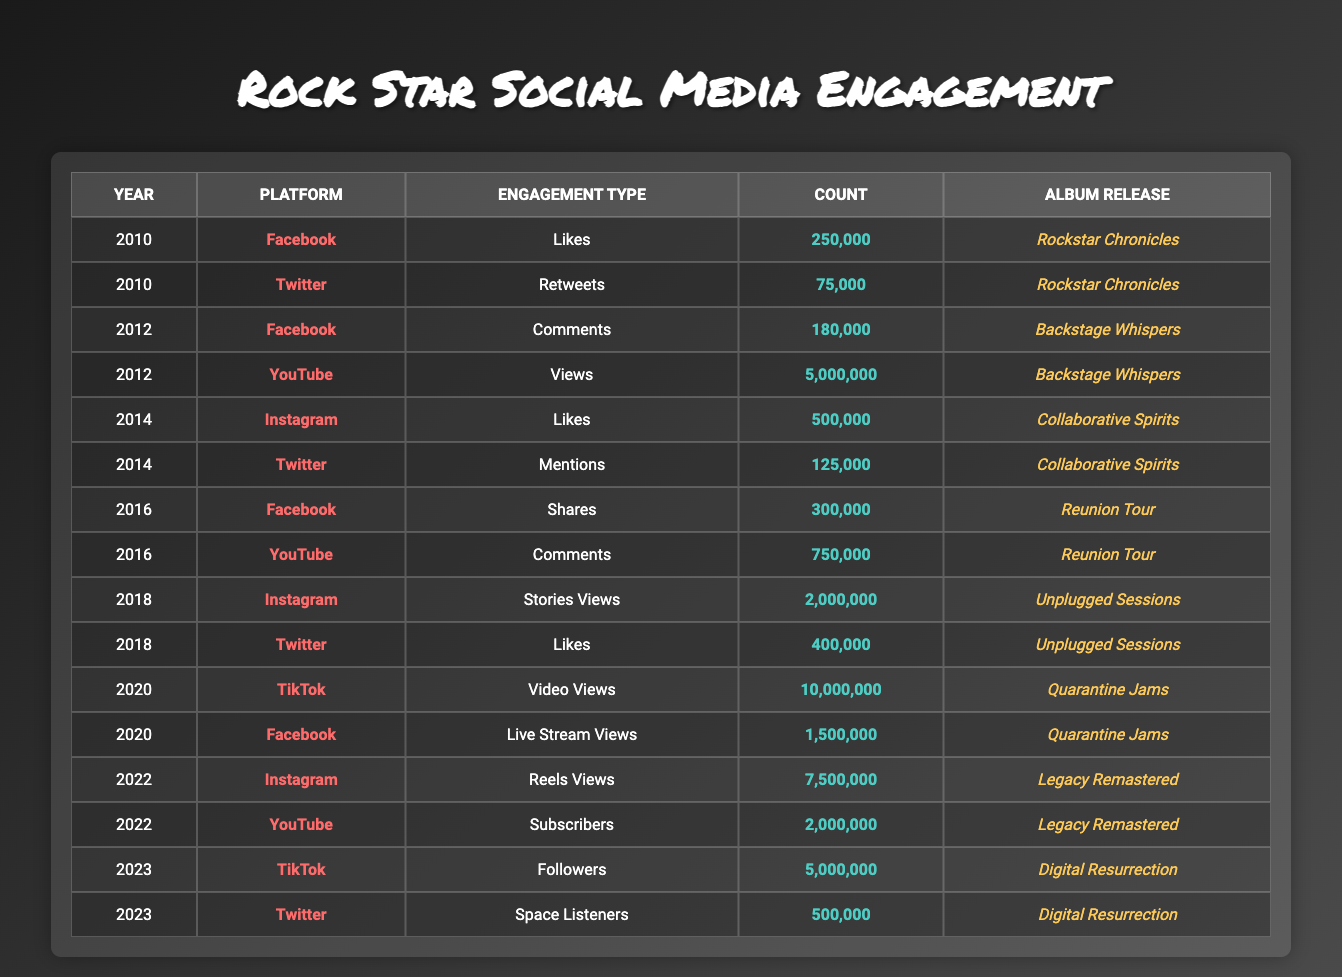What was the highest engagement count on Facebook, and in which year did it occur? From the table, the engagement counts for Facebook are 250,000 (2010), 180,000 (2012), and 1,500,000 (2020) for Likes, Comments, and Live Stream Views, respectively. The highest value is 1,500,000 in 2020.
Answer: 1,500,000 in 2020 In 2018, which platform had the most engagement based on the count of Likes, and what was that count? In 2018, the engagements on Twitter were 400,000 Likes, and Instagram had 2,000,000 Stories Views. There were no other types of Likes reported. Since Instagram’s Stories Views isn’t considered a Like, Twitter has the highest count of Likes with 400,000.
Answer: 400,000 What is the total number of video-related engagements across all platforms for the year 2020? In 2020, TikTok had 10,000,000 Video Views and Facebook had 1,500,000 Live Stream Views. Adding these gives 10,000,000 + 1,500,000 = 11,500,000 video-related engagements.
Answer: 11,500,000 Did the engagement count for TikTok increase from 2020 to 2023? In 2020, TikTok had 10,000,000 Video Views, while in 2023, it had 5,000,000 Followers. The engagement count decreased, so the statement is false.
Answer: No What was the average engagement count for Instagram across the available years? The total engagement counts for Instagram are 500,000 (2014 Likes), 2,000,000 (2018 Stories Views), and 7,500,000 (2022 Reels Views). This sums to 10,000,000, and with three data points, the average is 10,000,000 / 3 = 3,333,333.33.
Answer: 3,333,333.33 In which year did you have the highest engagement count for YouTube, and what type of engagement was it? The year with the highest engagement for YouTube was 2012, with 5,000,000 Views, the only other engagement type recorded is 750,000 Comments in 2016, which is lower.
Answer: 2012, Views Which platform had the least engagement among all recorded types in 2010? In 2010, the data shows 250,000 Likes for Facebook and 75,000 Retweets for Twitter. The lowest engagement type here is Twitter with 75,000.
Answer: Twitter with 75,000 Was there any year without engagement recorded for Twitter in the table? The years presented are 2010, 2012, 2014, 2016, 2018, 2020, 2023; Twitter has engagement recorded for all but 2012. This confirms that 2012 did not have any Twitter engagement data.
Answer: Yes 